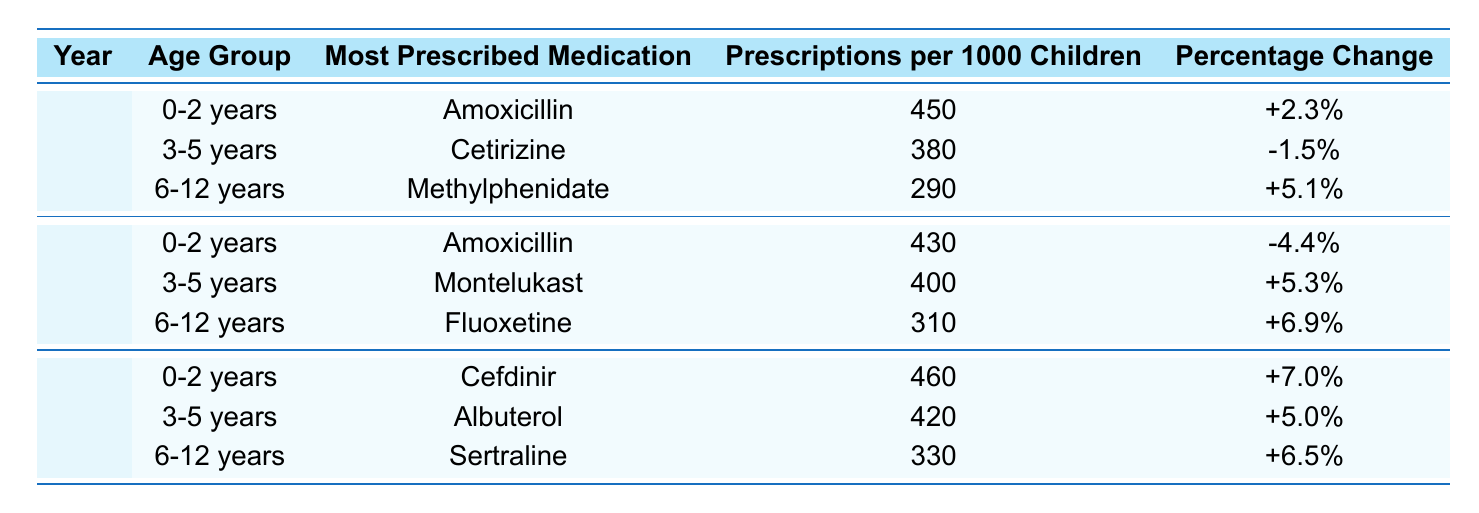What was the most prescribed medication for the 0-2 years age group in 2021? The table indicates that for the 0-2 years age group in 2021, the most prescribed medication was Amoxicillin.
Answer: Amoxicillin How many prescriptions per 1000 children were recorded for the 3-5 years age group in 2022? Referring to the table, the prescriptions per 1000 children for the 3-5 years age group in 2022 is 420.
Answer: 420 Which medication had a negative percentage change from the previous year in 2020? According to the table, Cetirizine for the 3-5 years age group in 2020 had a negative percentage change of -1.5%.
Answer: Cetirizine What is the total number of prescriptions per 1000 children for the 6-12 years age group across all years? The total number of prescriptions per 1000 children across the 6-12 years age group is calculated as follows: 290 (2020) + 310 (2021) + 330 (2022) = 930.
Answer: 930 Did the percentage of prescriptions for the 0-2 years age group increase or decrease from 2021 to 2022? For the 0-2 years age group, the percentage change from 2021 to 2022 is from -4.4% to +7.0%, indicating an increase.
Answer: Increase Which age group had the highest prescription increase from 2021 to 2022? Analyzing the percentage change, the 0-2 years age group had an increase of 7.0% from 2021 to 2022 compared to 5.3% for 3-5 years and 6.5% for 6-12 years. Thus, the highest increase is in the 0-2 years age group.
Answer: 0-2 years In which year did the 6-12 years age group see the most prescriptions per 1000 children, and what was that number? Reviewing the table, the 6-12 years age group had the highest prescriptions in 2022 with 330 prescriptions per 1000 children.
Answer: 330 in 2022 What was the overall trend for the 3-5 years age group from 2020 to 2022 in terms of prescriptions per 1000 children? Examining the values, prescriptions per 1000 children for the 3-5 years age group were 380 (2020), 400 (2021), and 420 (2022), showing a consistent increase each year.
Answer: Overall increasing trend Is it true that the most prescribed medication for the 6-12 years age group remained the same from 2020 to 2021? According to the table, the medication changed from Methylphenidate (2020) to Fluoxetine (2021), so this statement is false.
Answer: False What was the average number of prescriptions per 1000 children for the 0-2 years age group over the three years? Calculating the average: (450 + 430 + 460) / 3 = 460. Thus, the average number of prescriptions per 1000 children for the 0-2 years age group is 460.
Answer: 460 